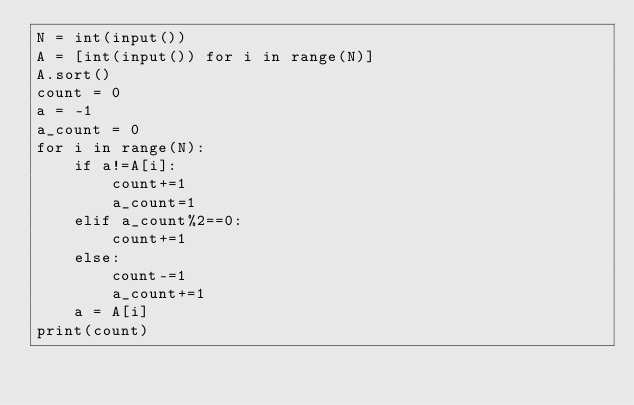Convert code to text. <code><loc_0><loc_0><loc_500><loc_500><_Python_>N = int(input())
A = [int(input()) for i in range(N)]
A.sort()
count = 0
a = -1
a_count = 0
for i in range(N):
    if a!=A[i]:
        count+=1
        a_count=1
    elif a_count%2==0:
        count+=1
    else:
        count-=1
        a_count+=1
    a = A[i]
print(count)</code> 